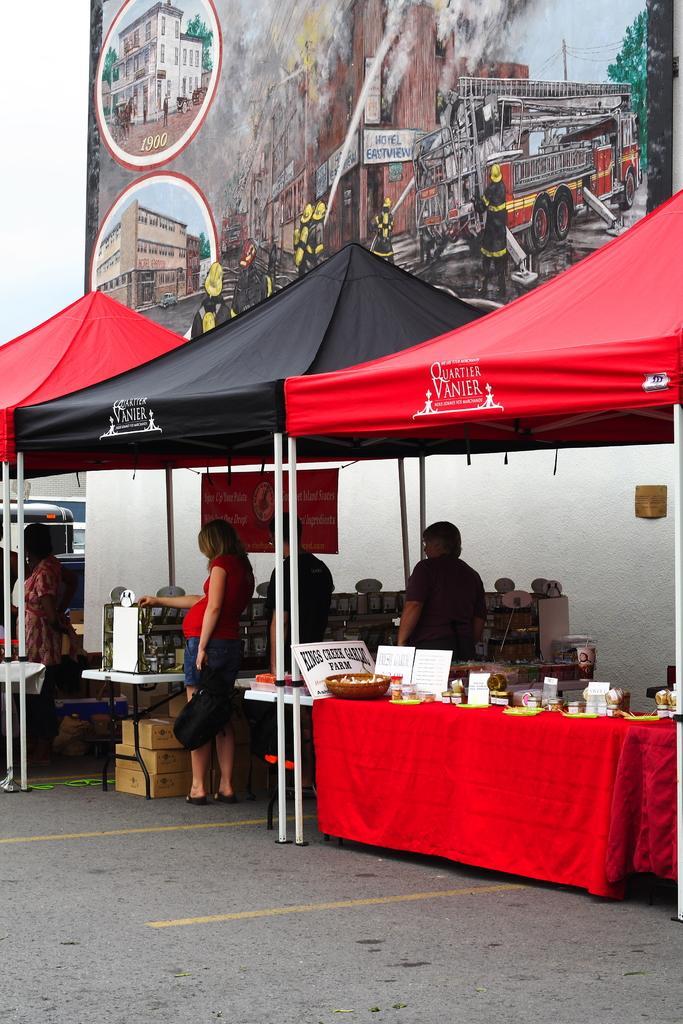In one or two sentences, can you explain what this image depicts? In this image, There is a road gray color, There is a red color shed and there are some objects placed on the red color table, In the background there is a wall of white color on that there is a poster of brown color and there are some people standing in the shade of black color. 